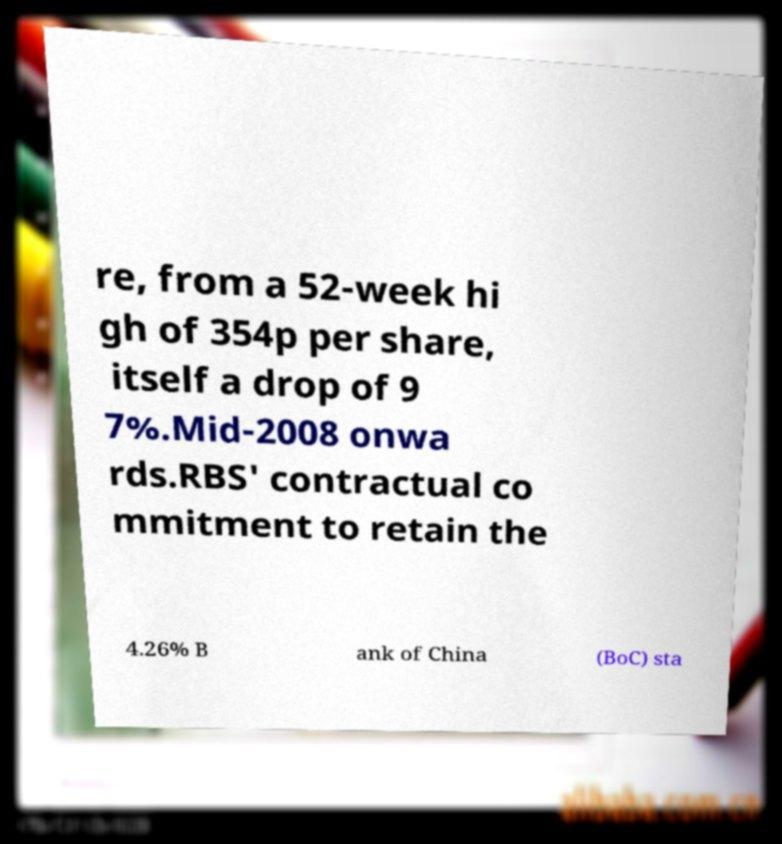What messages or text are displayed in this image? I need them in a readable, typed format. re, from a 52-week hi gh of 354p per share, itself a drop of 9 7%.Mid-2008 onwa rds.RBS' contractual co mmitment to retain the 4.26% B ank of China (BoC) sta 